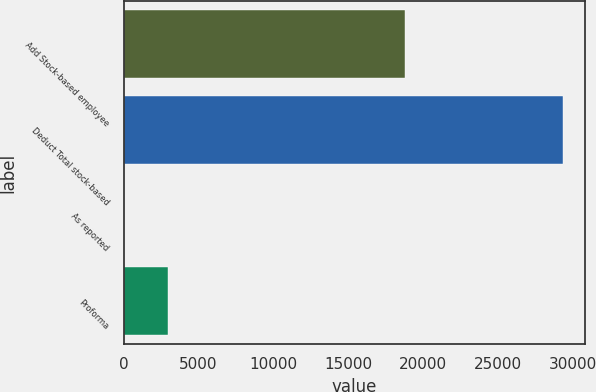Convert chart. <chart><loc_0><loc_0><loc_500><loc_500><bar_chart><fcel>Add Stock-based employee<fcel>Deduct Total stock-based<fcel>As reported<fcel>Proforma<nl><fcel>18784<fcel>29350<fcel>1.52<fcel>2936.37<nl></chart> 